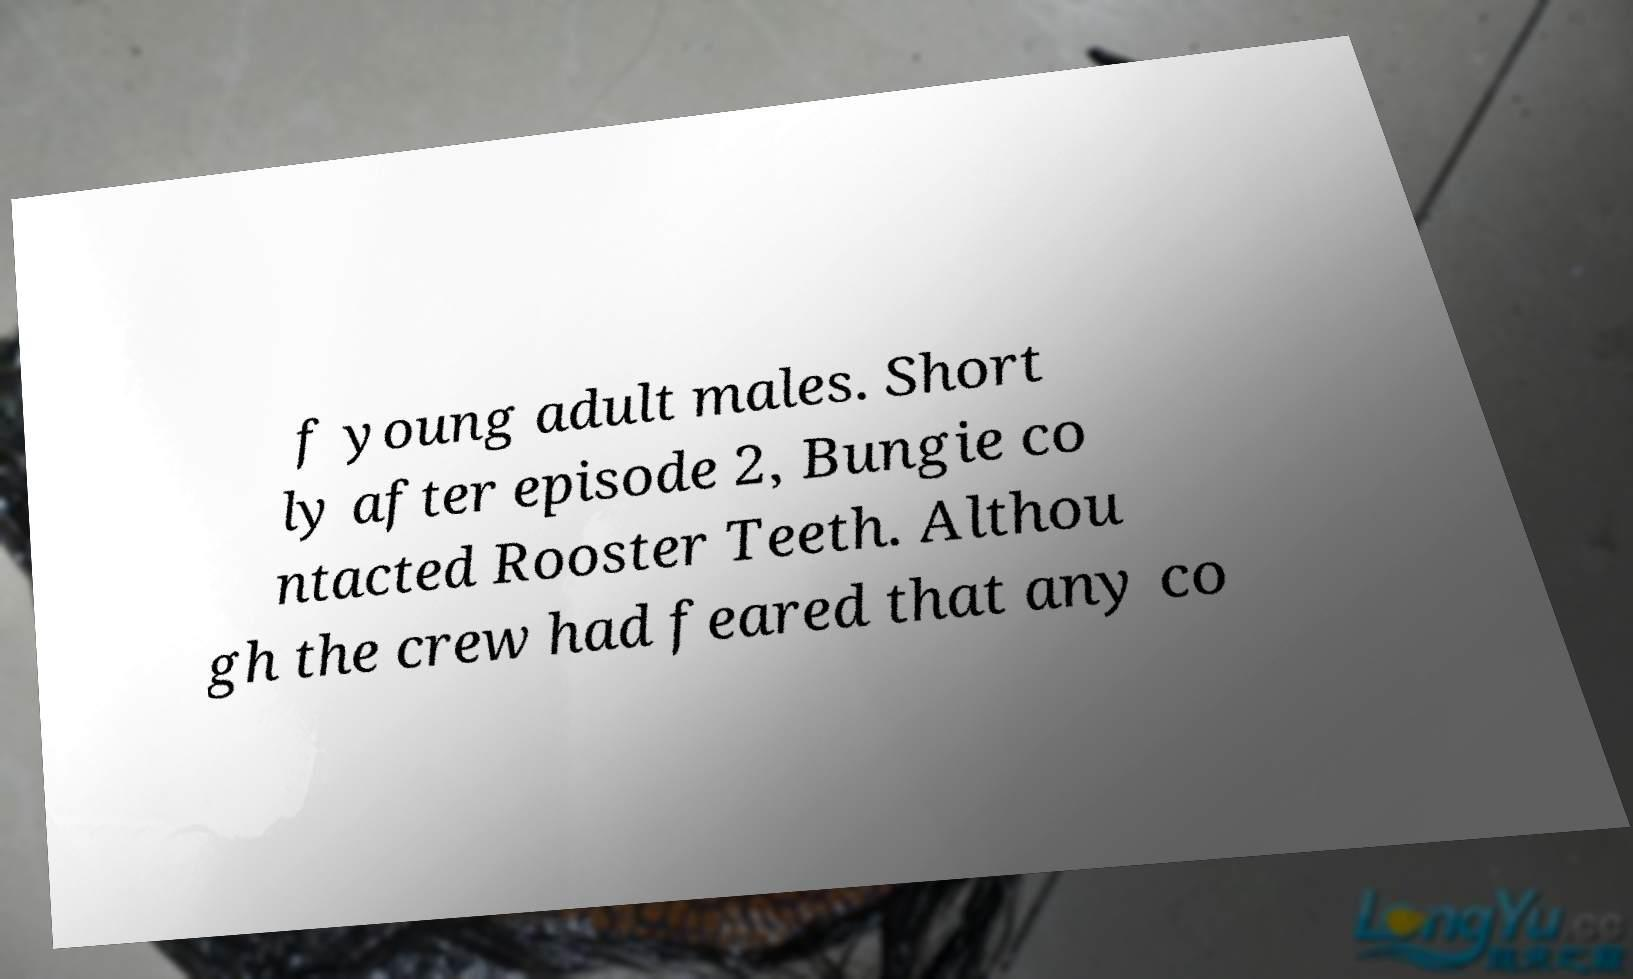What messages or text are displayed in this image? I need them in a readable, typed format. f young adult males. Short ly after episode 2, Bungie co ntacted Rooster Teeth. Althou gh the crew had feared that any co 